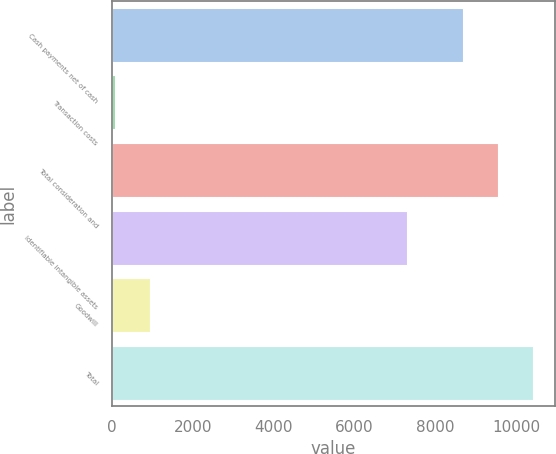Convert chart to OTSL. <chart><loc_0><loc_0><loc_500><loc_500><bar_chart><fcel>Cash payments net of cash<fcel>Transaction costs<fcel>Total consideration and<fcel>Identifiable intangible assets<fcel>Goodwill<fcel>Total<nl><fcel>8696<fcel>68<fcel>9565.6<fcel>7300<fcel>937.6<fcel>10435.2<nl></chart> 